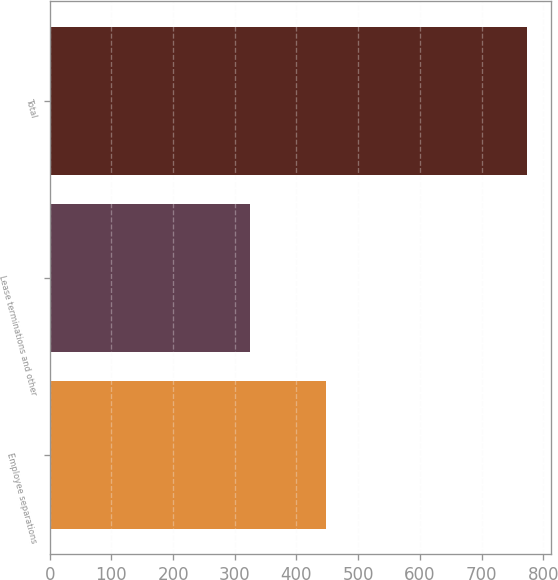Convert chart to OTSL. <chart><loc_0><loc_0><loc_500><loc_500><bar_chart><fcel>Employee separations<fcel>Lease terminations and other<fcel>Total<nl><fcel>448<fcel>325<fcel>773<nl></chart> 